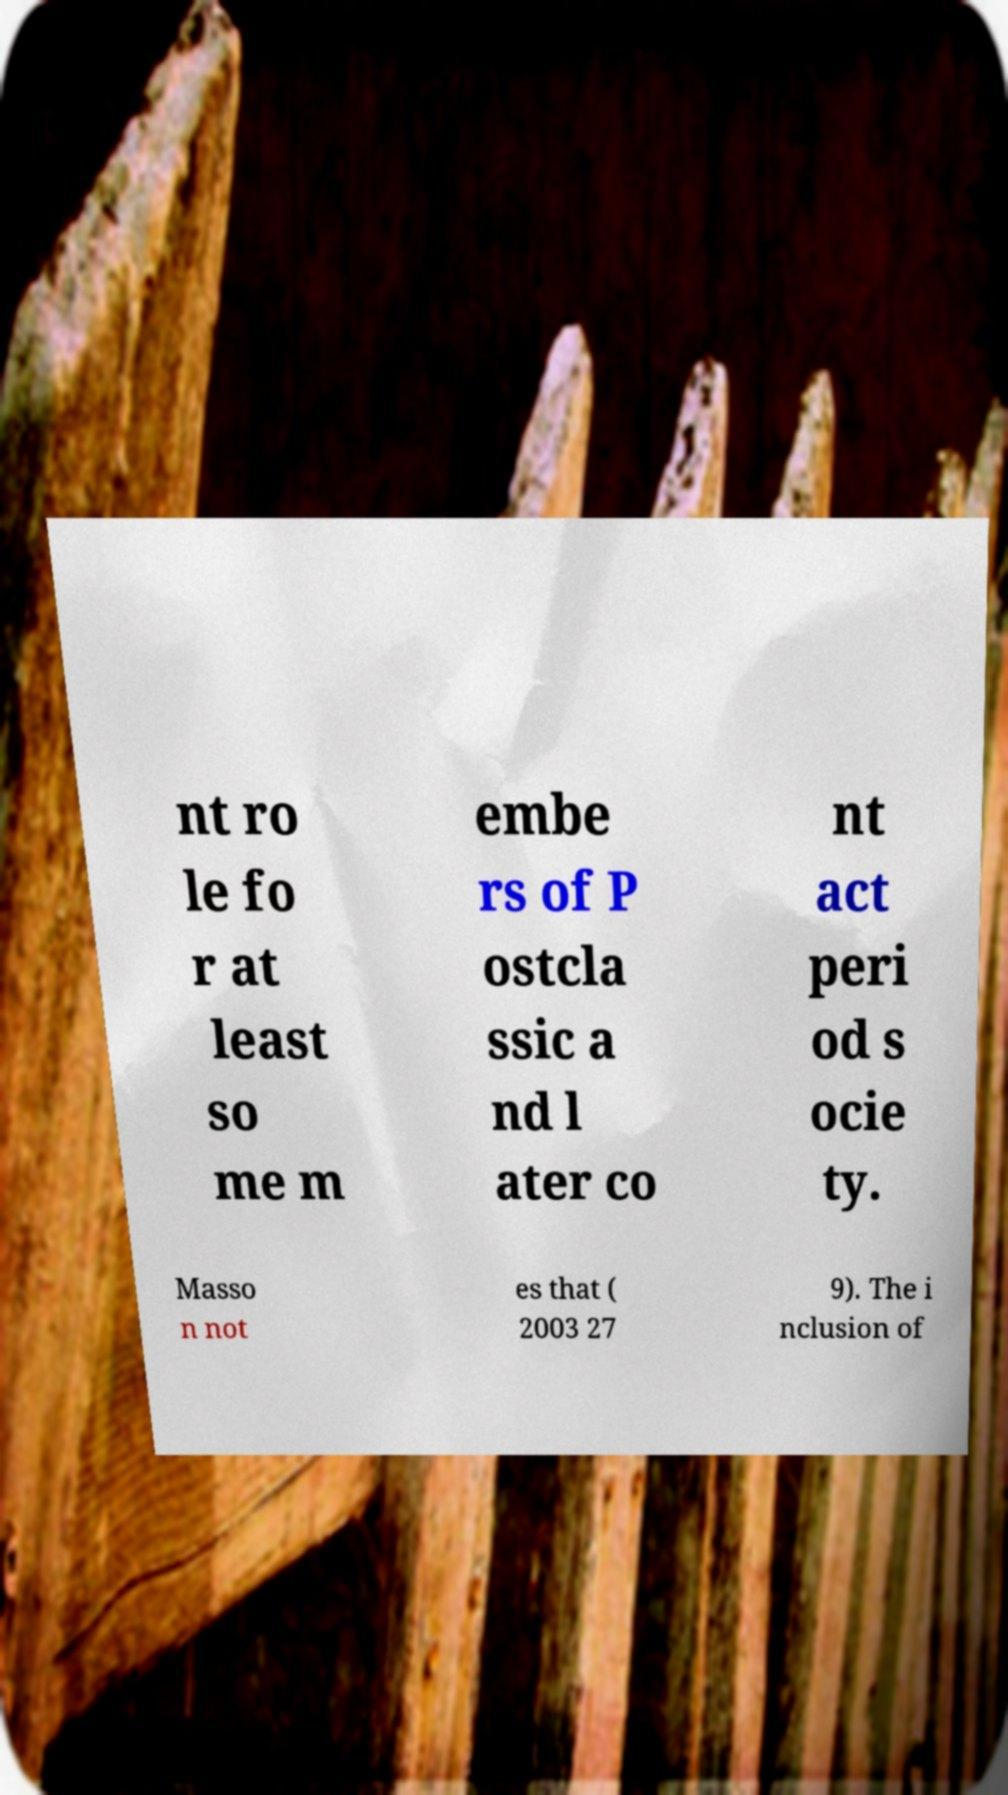There's text embedded in this image that I need extracted. Can you transcribe it verbatim? nt ro le fo r at least so me m embe rs of P ostcla ssic a nd l ater co nt act peri od s ocie ty. Masso n not es that ( 2003 27 9). The i nclusion of 